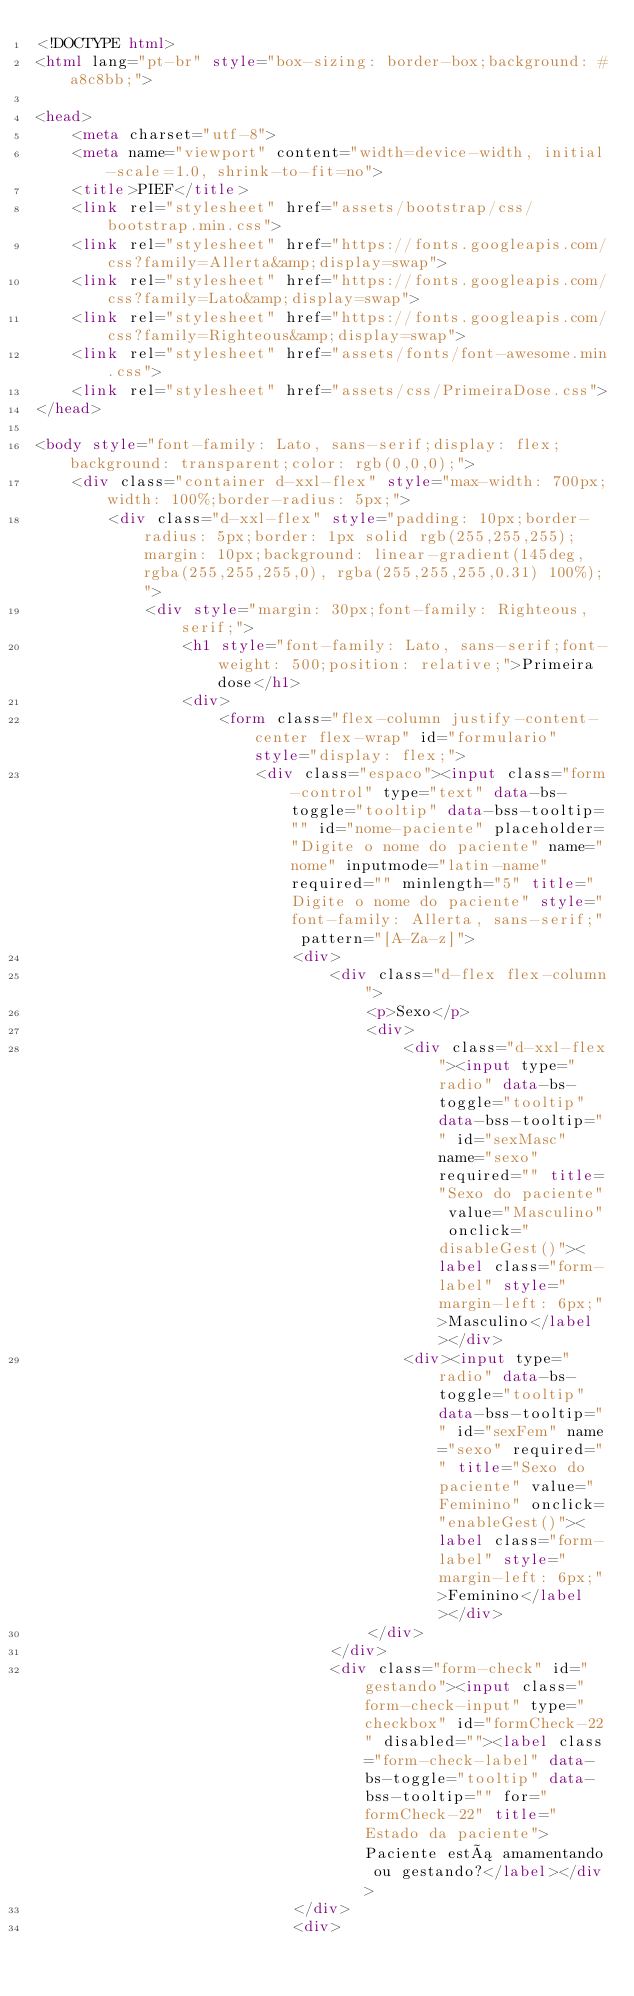Convert code to text. <code><loc_0><loc_0><loc_500><loc_500><_HTML_><!DOCTYPE html>
<html lang="pt-br" style="box-sizing: border-box;background: #a8c8bb;">

<head>
    <meta charset="utf-8">
    <meta name="viewport" content="width=device-width, initial-scale=1.0, shrink-to-fit=no">
    <title>PIEF</title>
    <link rel="stylesheet" href="assets/bootstrap/css/bootstrap.min.css">
    <link rel="stylesheet" href="https://fonts.googleapis.com/css?family=Allerta&amp;display=swap">
    <link rel="stylesheet" href="https://fonts.googleapis.com/css?family=Lato&amp;display=swap">
    <link rel="stylesheet" href="https://fonts.googleapis.com/css?family=Righteous&amp;display=swap">
    <link rel="stylesheet" href="assets/fonts/font-awesome.min.css">
    <link rel="stylesheet" href="assets/css/PrimeiraDose.css">
</head>

<body style="font-family: Lato, sans-serif;display: flex;background: transparent;color: rgb(0,0,0);">
    <div class="container d-xxl-flex" style="max-width: 700px;width: 100%;border-radius: 5px;">
        <div class="d-xxl-flex" style="padding: 10px;border-radius: 5px;border: 1px solid rgb(255,255,255);margin: 10px;background: linear-gradient(145deg, rgba(255,255,255,0), rgba(255,255,255,0.31) 100%);">
            <div style="margin: 30px;font-family: Righteous, serif;">
                <h1 style="font-family: Lato, sans-serif;font-weight: 500;position: relative;">Primeira dose</h1>
                <div>
                    <form class="flex-column justify-content-center flex-wrap" id="formulario" style="display: flex;">
                        <div class="espaco"><input class="form-control" type="text" data-bs-toggle="tooltip" data-bss-tooltip="" id="nome-paciente" placeholder="Digite o nome do paciente" name="nome" inputmode="latin-name" required="" minlength="5" title="Digite o nome do paciente" style="font-family: Allerta, sans-serif;" pattern="[A-Za-z]">
                            <div>
                                <div class="d-flex flex-column">
                                    <p>Sexo</p>
                                    <div>
                                        <div class="d-xxl-flex"><input type="radio" data-bs-toggle="tooltip" data-bss-tooltip="" id="sexMasc" name="sexo" required="" title="Sexo do paciente" value="Masculino" onclick="disableGest()"><label class="form-label" style="margin-left: 6px;">Masculino</label></div>
                                        <div><input type="radio" data-bs-toggle="tooltip" data-bss-tooltip="" id="sexFem" name="sexo" required="" title="Sexo do paciente" value="Feminino" onclick="enableGest()"><label class="form-label" style="margin-left: 6px;">Feminino</label></div>
                                    </div>
                                </div>
                                <div class="form-check" id="gestando"><input class="form-check-input" type="checkbox" id="formCheck-22" disabled=""><label class="form-check-label" data-bs-toggle="tooltip" data-bss-tooltip="" for="formCheck-22" title="Estado da paciente">Paciente está amamentando ou gestando?</label></div>
                            </div>
                            <div></code> 